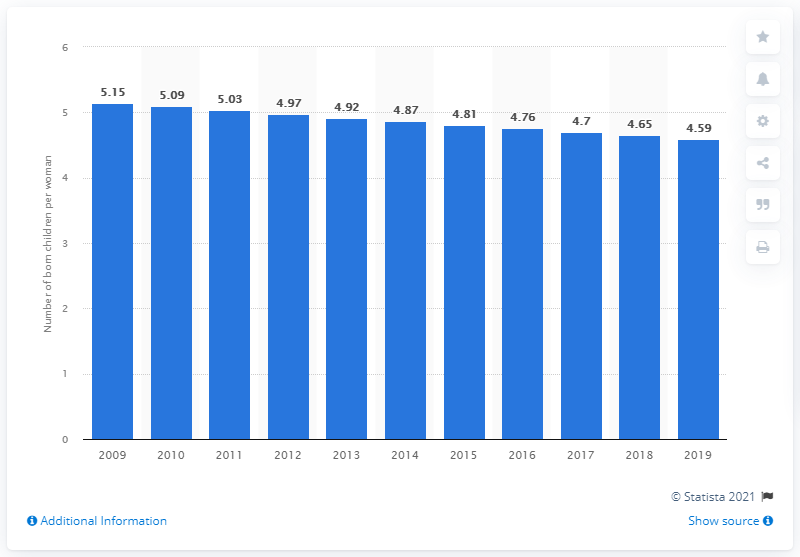Specify some key components in this picture. In 2019, the fertility rate in Ivory Coast was 4.59. 